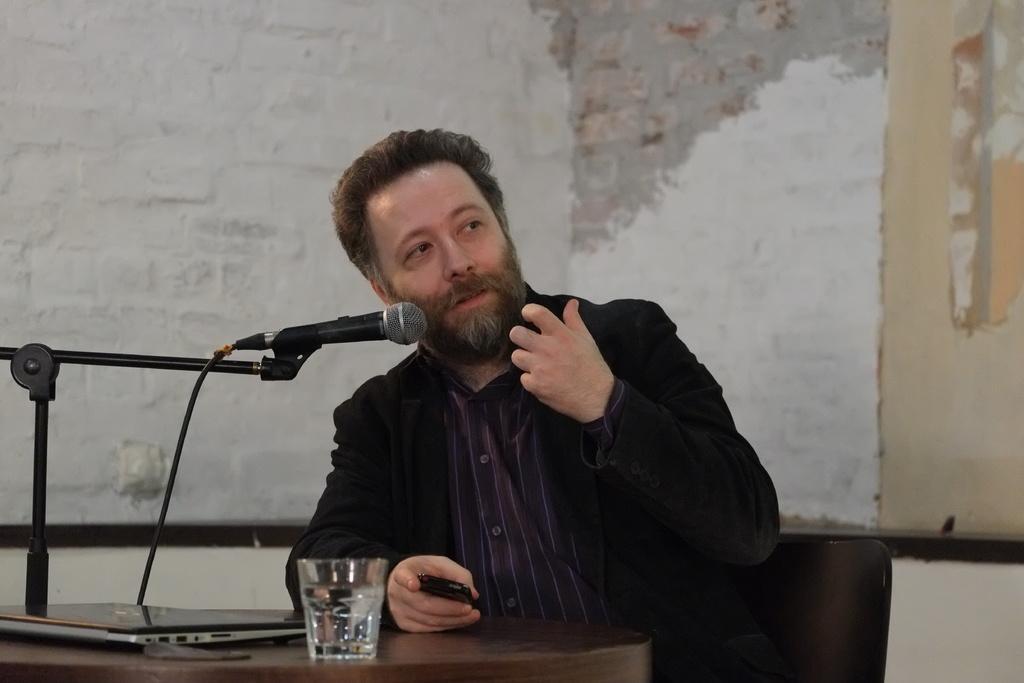Can you describe this image briefly? In this image in the front there is a table and on the table there is a glass, laptop and mic. In the center there is a person and in the background there is a wall which seems to be like half painted. 